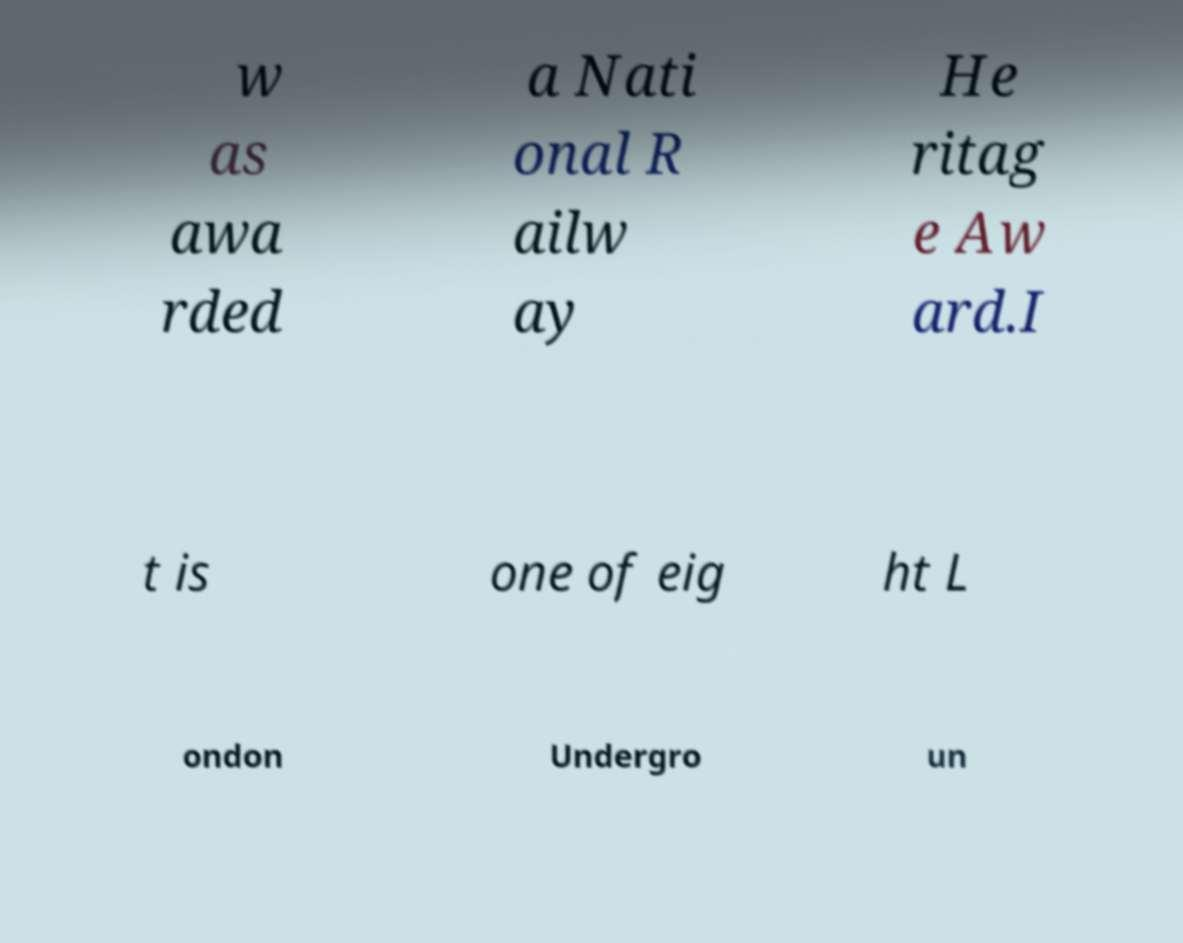Can you read and provide the text displayed in the image?This photo seems to have some interesting text. Can you extract and type it out for me? w as awa rded a Nati onal R ailw ay He ritag e Aw ard.I t is one of eig ht L ondon Undergro un 